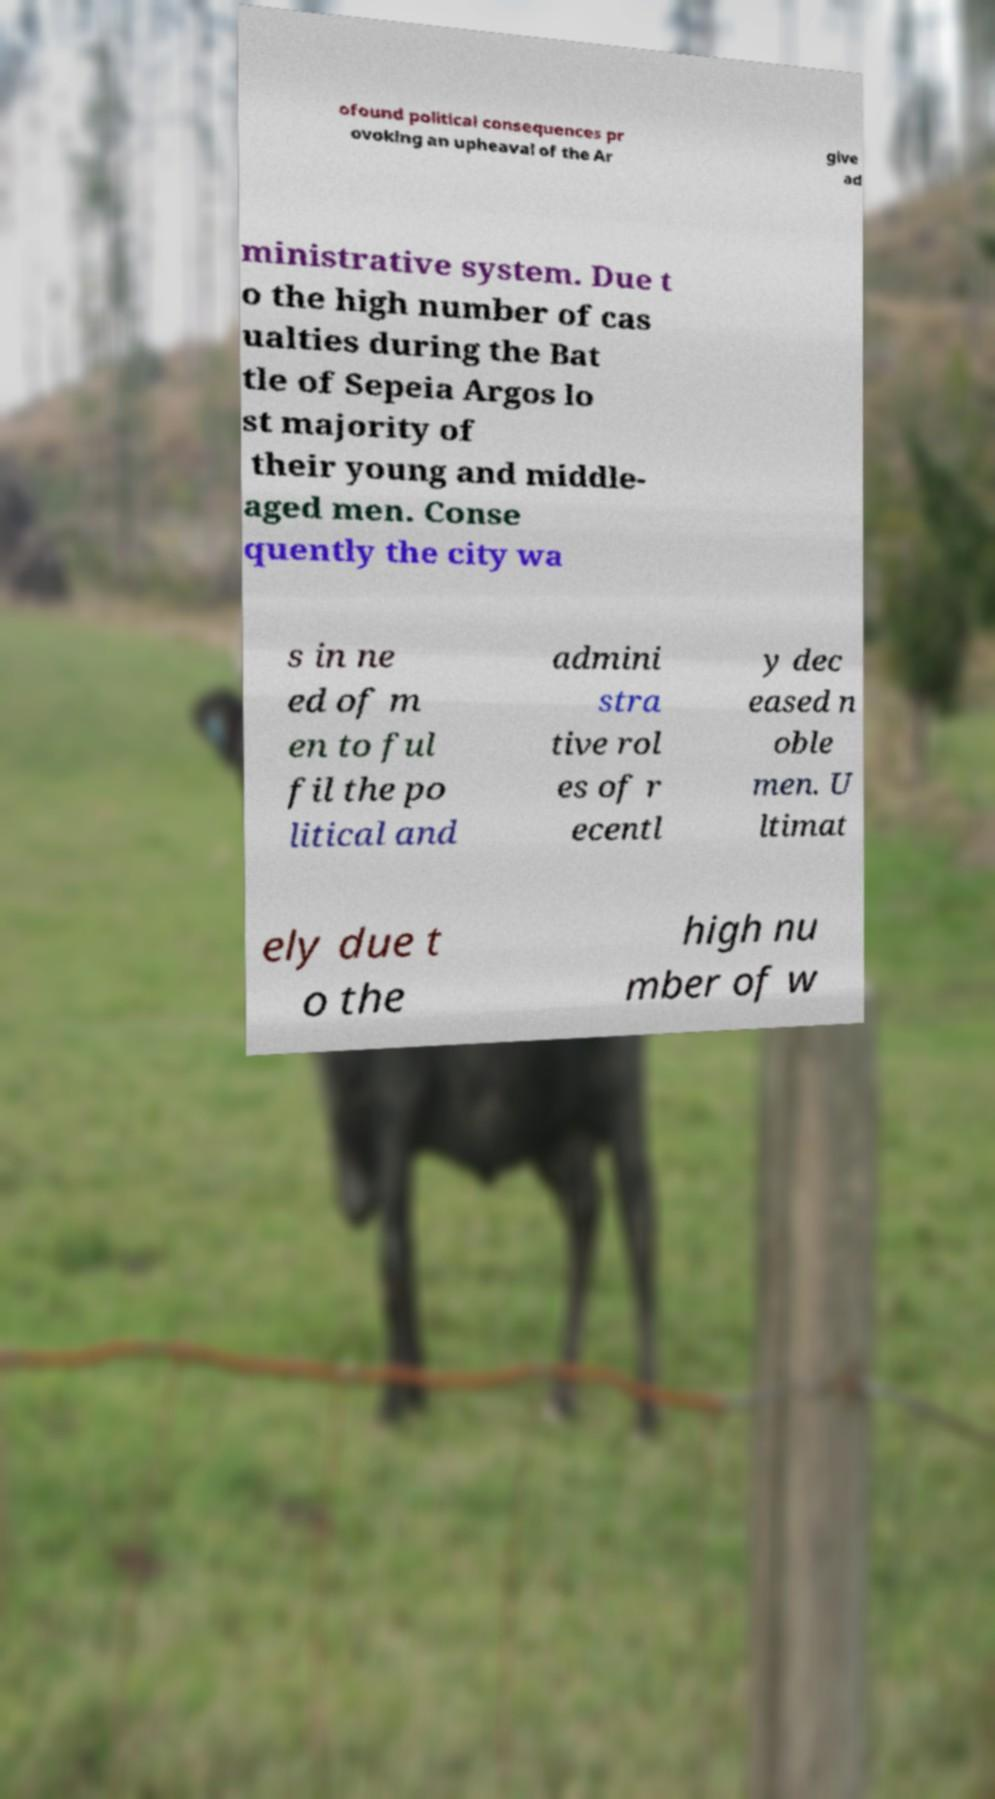What messages or text are displayed in this image? I need them in a readable, typed format. ofound political consequences pr ovoking an upheaval of the Ar give ad ministrative system. Due t o the high number of cas ualties during the Bat tle of Sepeia Argos lo st majority of their young and middle- aged men. Conse quently the city wa s in ne ed of m en to ful fil the po litical and admini stra tive rol es of r ecentl y dec eased n oble men. U ltimat ely due t o the high nu mber of w 